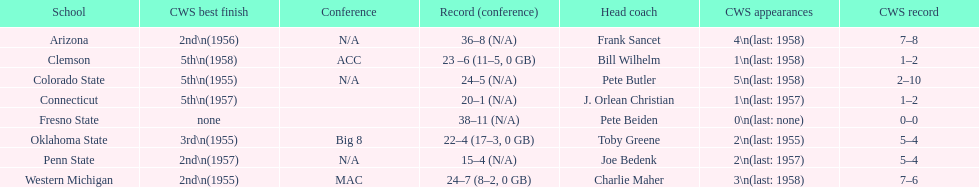Which school has no cws appearances? Fresno State. Can you parse all the data within this table? {'header': ['School', 'CWS best finish', 'Conference', 'Record (conference)', 'Head coach', 'CWS appearances', 'CWS record'], 'rows': [['Arizona', '2nd\\n(1956)', 'N/A', '36–8 (N/A)', 'Frank Sancet', '4\\n(last: 1958)', '7–8'], ['Clemson', '5th\\n(1958)', 'ACC', '23 –6 (11–5, 0 GB)', 'Bill Wilhelm', '1\\n(last: 1958)', '1–2'], ['Colorado State', '5th\\n(1955)', 'N/A', '24–5 (N/A)', 'Pete Butler', '5\\n(last: 1958)', '2–10'], ['Connecticut', '5th\\n(1957)', '', '20–1 (N/A)', 'J. Orlean Christian', '1\\n(last: 1957)', '1–2'], ['Fresno State', 'none', '', '38–11 (N/A)', 'Pete Beiden', '0\\n(last: none)', '0–0'], ['Oklahoma State', '3rd\\n(1955)', 'Big 8', '22–4 (17–3, 0 GB)', 'Toby Greene', '2\\n(last: 1955)', '5–4'], ['Penn State', '2nd\\n(1957)', 'N/A', '15–4 (N/A)', 'Joe Bedenk', '2\\n(last: 1957)', '5–4'], ['Western Michigan', '2nd\\n(1955)', 'MAC', '24–7 (8–2, 0 GB)', 'Charlie Maher', '3\\n(last: 1958)', '7–6']]} 